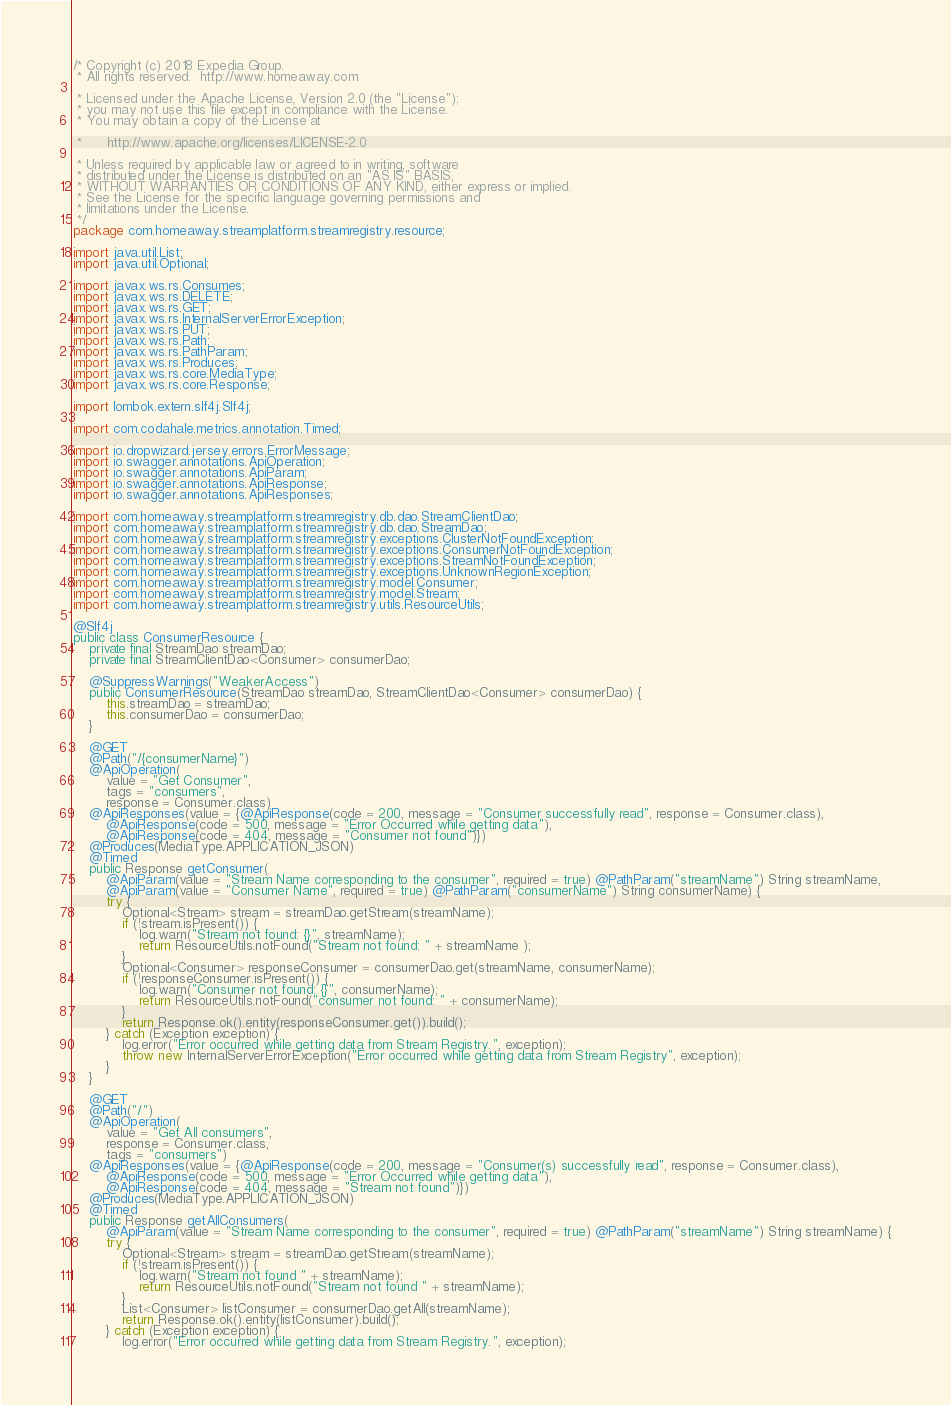Convert code to text. <code><loc_0><loc_0><loc_500><loc_500><_Java_>/* Copyright (c) 2018 Expedia Group.
 * All rights reserved.  http://www.homeaway.com

 * Licensed under the Apache License, Version 2.0 (the "License");
 * you may not use this file except in compliance with the License.
 * You may obtain a copy of the License at

 *      http://www.apache.org/licenses/LICENSE-2.0

 * Unless required by applicable law or agreed to in writing, software
 * distributed under the License is distributed on an "AS IS" BASIS,
 * WITHOUT WARRANTIES OR CONDITIONS OF ANY KIND, either express or implied.
 * See the License for the specific language governing permissions and
 * limitations under the License.
 */
package com.homeaway.streamplatform.streamregistry.resource;

import java.util.List;
import java.util.Optional;

import javax.ws.rs.Consumes;
import javax.ws.rs.DELETE;
import javax.ws.rs.GET;
import javax.ws.rs.InternalServerErrorException;
import javax.ws.rs.PUT;
import javax.ws.rs.Path;
import javax.ws.rs.PathParam;
import javax.ws.rs.Produces;
import javax.ws.rs.core.MediaType;
import javax.ws.rs.core.Response;

import lombok.extern.slf4j.Slf4j;

import com.codahale.metrics.annotation.Timed;

import io.dropwizard.jersey.errors.ErrorMessage;
import io.swagger.annotations.ApiOperation;
import io.swagger.annotations.ApiParam;
import io.swagger.annotations.ApiResponse;
import io.swagger.annotations.ApiResponses;

import com.homeaway.streamplatform.streamregistry.db.dao.StreamClientDao;
import com.homeaway.streamplatform.streamregistry.db.dao.StreamDao;
import com.homeaway.streamplatform.streamregistry.exceptions.ClusterNotFoundException;
import com.homeaway.streamplatform.streamregistry.exceptions.ConsumerNotFoundException;
import com.homeaway.streamplatform.streamregistry.exceptions.StreamNotFoundException;
import com.homeaway.streamplatform.streamregistry.exceptions.UnknownRegionException;
import com.homeaway.streamplatform.streamregistry.model.Consumer;
import com.homeaway.streamplatform.streamregistry.model.Stream;
import com.homeaway.streamplatform.streamregistry.utils.ResourceUtils;

@Slf4j
public class ConsumerResource {
    private final StreamDao streamDao;
    private final StreamClientDao<Consumer> consumerDao;

    @SuppressWarnings("WeakerAccess")
    public ConsumerResource(StreamDao streamDao, StreamClientDao<Consumer> consumerDao) {
        this.streamDao = streamDao;
        this.consumerDao = consumerDao;
    }

    @GET
    @Path("/{consumerName}")
    @ApiOperation(
        value = "Get Consumer",
        tags = "consumers",
        response = Consumer.class)
    @ApiResponses(value = {@ApiResponse(code = 200, message = "Consumer successfully read", response = Consumer.class),
        @ApiResponse(code = 500, message = "Error Occurred while getting data"),
        @ApiResponse(code = 404, message = "Consumer not found")})
    @Produces(MediaType.APPLICATION_JSON)
    @Timed
    public Response getConsumer(
        @ApiParam(value = "Stream Name corresponding to the consumer", required = true) @PathParam("streamName") String streamName,
        @ApiParam(value = "Consumer Name", required = true) @PathParam("consumerName") String consumerName) {
        try {
            Optional<Stream> stream = streamDao.getStream(streamName);
            if (!stream.isPresent()) {
                log.warn("Stream not found: {}", streamName);
                return ResourceUtils.notFound("Stream not found: " + streamName );
            }
            Optional<Consumer> responseConsumer = consumerDao.get(streamName, consumerName);
            if (!responseConsumer.isPresent()) {
                log.warn("Consumer not found: {}", consumerName);
                return ResourceUtils.notFound("consumer not found: " + consumerName);
            }
            return Response.ok().entity(responseConsumer.get()).build();
        } catch (Exception exception) {
            log.error("Error occurred while getting data from Stream Registry.", exception);
            throw new InternalServerErrorException("Error occurred while getting data from Stream Registry", exception);
        }
    }

    @GET
    @Path("/")
    @ApiOperation(
        value = "Get All consumers",
        response = Consumer.class,
        tags = "consumers")
    @ApiResponses(value = {@ApiResponse(code = 200, message = "Consumer(s) successfully read", response = Consumer.class),
        @ApiResponse(code = 500, message = "Error Occurred while getting data"),
        @ApiResponse(code = 404, message = "Stream not found")})
    @Produces(MediaType.APPLICATION_JSON)
    @Timed
    public Response getAllConsumers(
        @ApiParam(value = "Stream Name corresponding to the consumer", required = true) @PathParam("streamName") String streamName) {
        try {
            Optional<Stream> stream = streamDao.getStream(streamName);
            if (!stream.isPresent()) {
                log.warn("Stream not found " + streamName);
                return ResourceUtils.notFound("Stream not found " + streamName);
            }
            List<Consumer> listConsumer = consumerDao.getAll(streamName);
            return Response.ok().entity(listConsumer).build();
        } catch (Exception exception) {
            log.error("Error occurred while getting data from Stream Registry.", exception);</code> 